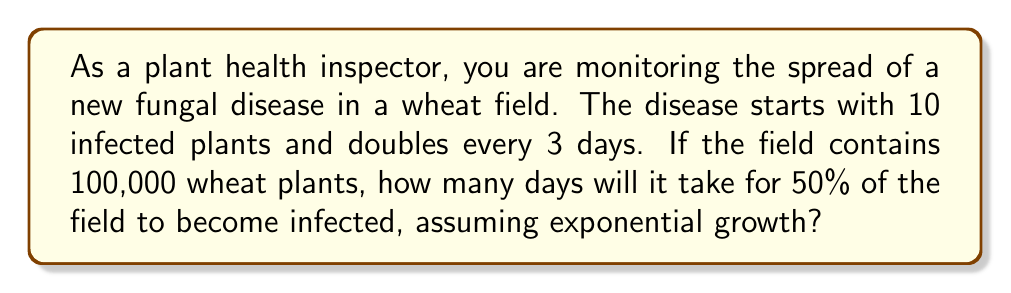What is the answer to this math problem? To solve this problem, we'll use the exponential growth model and work through the following steps:

1) Let's define our variables:
   $N_0$ = initial number of infected plants = 10
   $r$ = growth rate
   $t$ = time in days
   $N(t)$ = number of infected plants at time $t$

2) The exponential growth model is given by:
   $N(t) = N_0 \cdot e^{rt}$

3) We're told the population doubles every 3 days. We can use this to find $r$:
   $2N_0 = N_0 \cdot e^{r(3)}$
   $2 = e^{3r}$
   $\ln(2) = 3r$
   $r = \frac{\ln(2)}{3} \approx 0.231$ per day

4) Now, we want to find when 50% of the field (50,000 plants) is infected:
   $50,000 = 10 \cdot e^{0.231t}$

5) Solving for $t$:
   $5,000 = e^{0.231t}$
   $\ln(5,000) = 0.231t$
   $t = \frac{\ln(5,000)}{0.231} \approx 37.17$ days

Therefore, it will take approximately 37.17 days for 50% of the field to become infected.
Answer: 37.17 days 